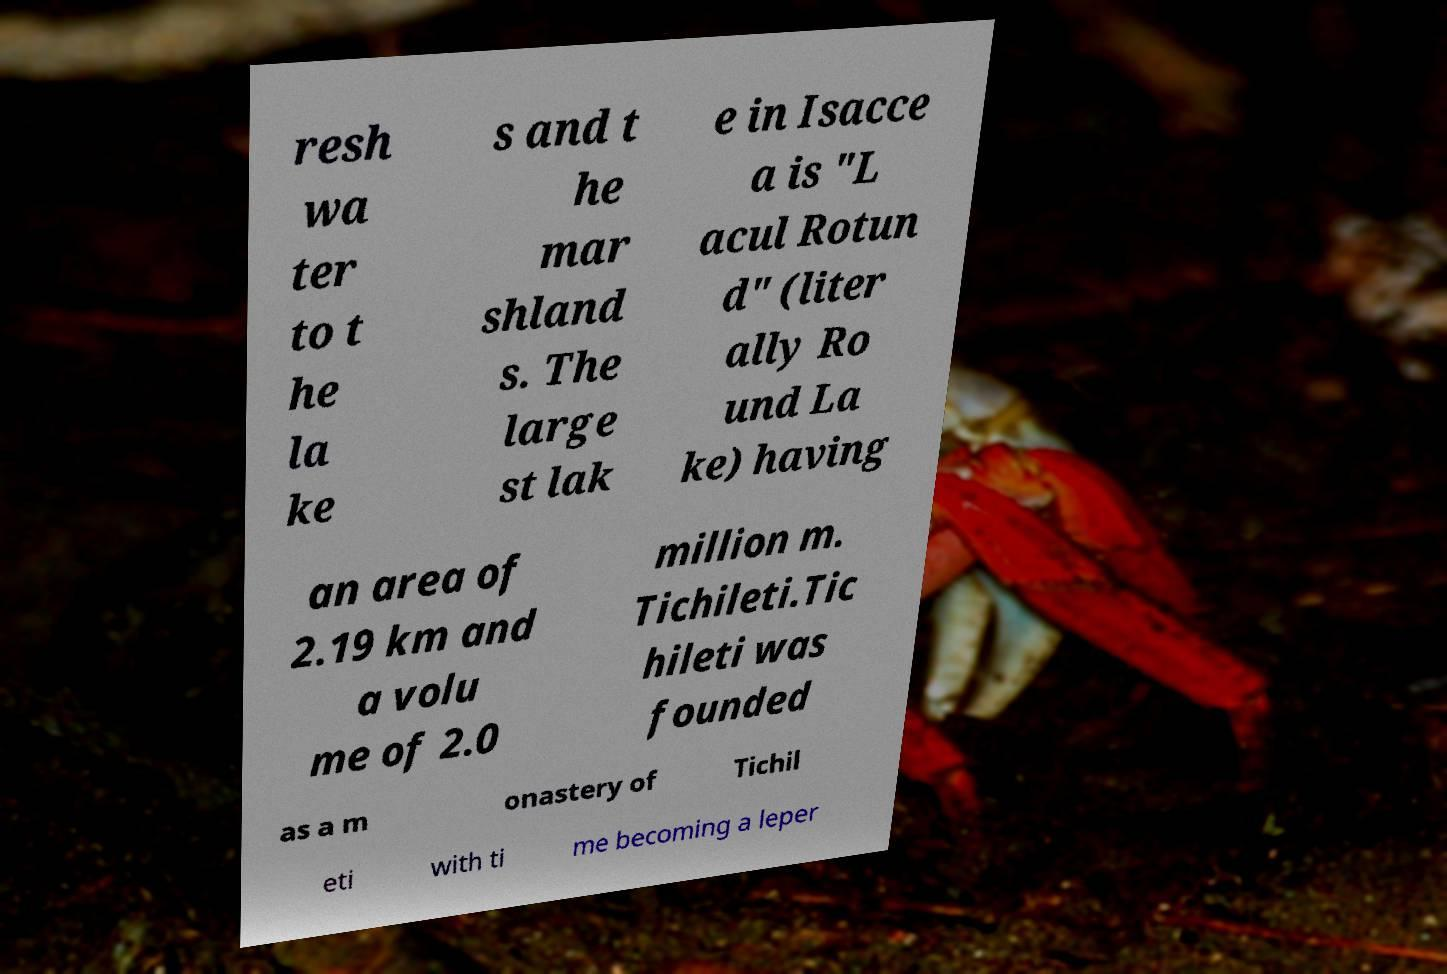Please identify and transcribe the text found in this image. resh wa ter to t he la ke s and t he mar shland s. The large st lak e in Isacce a is "L acul Rotun d" (liter ally Ro und La ke) having an area of 2.19 km and a volu me of 2.0 million m. Tichileti.Tic hileti was founded as a m onastery of Tichil eti with ti me becoming a leper 